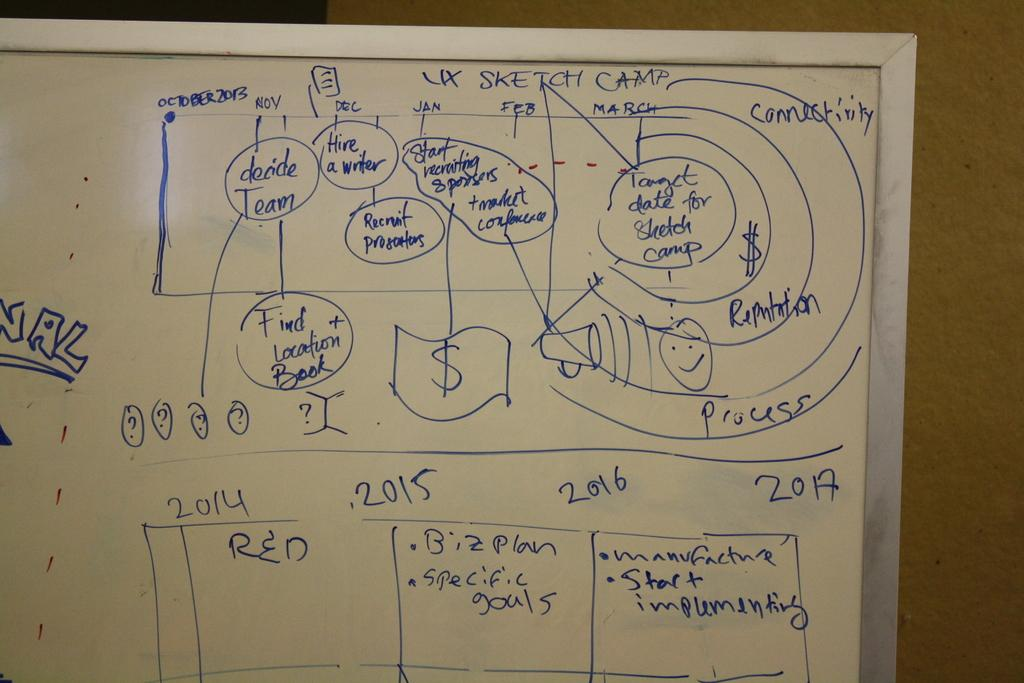<image>
Describe the image concisely. A whiteboard has information about the UX Sketch Camp drawn on it. 